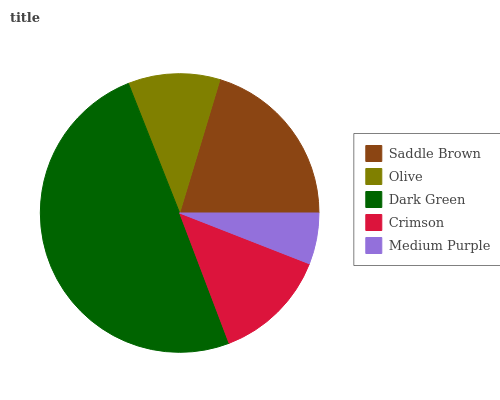Is Medium Purple the minimum?
Answer yes or no. Yes. Is Dark Green the maximum?
Answer yes or no. Yes. Is Olive the minimum?
Answer yes or no. No. Is Olive the maximum?
Answer yes or no. No. Is Saddle Brown greater than Olive?
Answer yes or no. Yes. Is Olive less than Saddle Brown?
Answer yes or no. Yes. Is Olive greater than Saddle Brown?
Answer yes or no. No. Is Saddle Brown less than Olive?
Answer yes or no. No. Is Crimson the high median?
Answer yes or no. Yes. Is Crimson the low median?
Answer yes or no. Yes. Is Dark Green the high median?
Answer yes or no. No. Is Olive the low median?
Answer yes or no. No. 